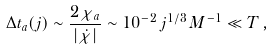<formula> <loc_0><loc_0><loc_500><loc_500>\Delta t _ { a } ( j ) \sim \frac { 2 \chi _ { a } } { | \dot { \chi } | } \sim 1 0 ^ { - 2 } \, j ^ { 1 / 3 } \, M ^ { - 1 } \ll T \, ,</formula> 